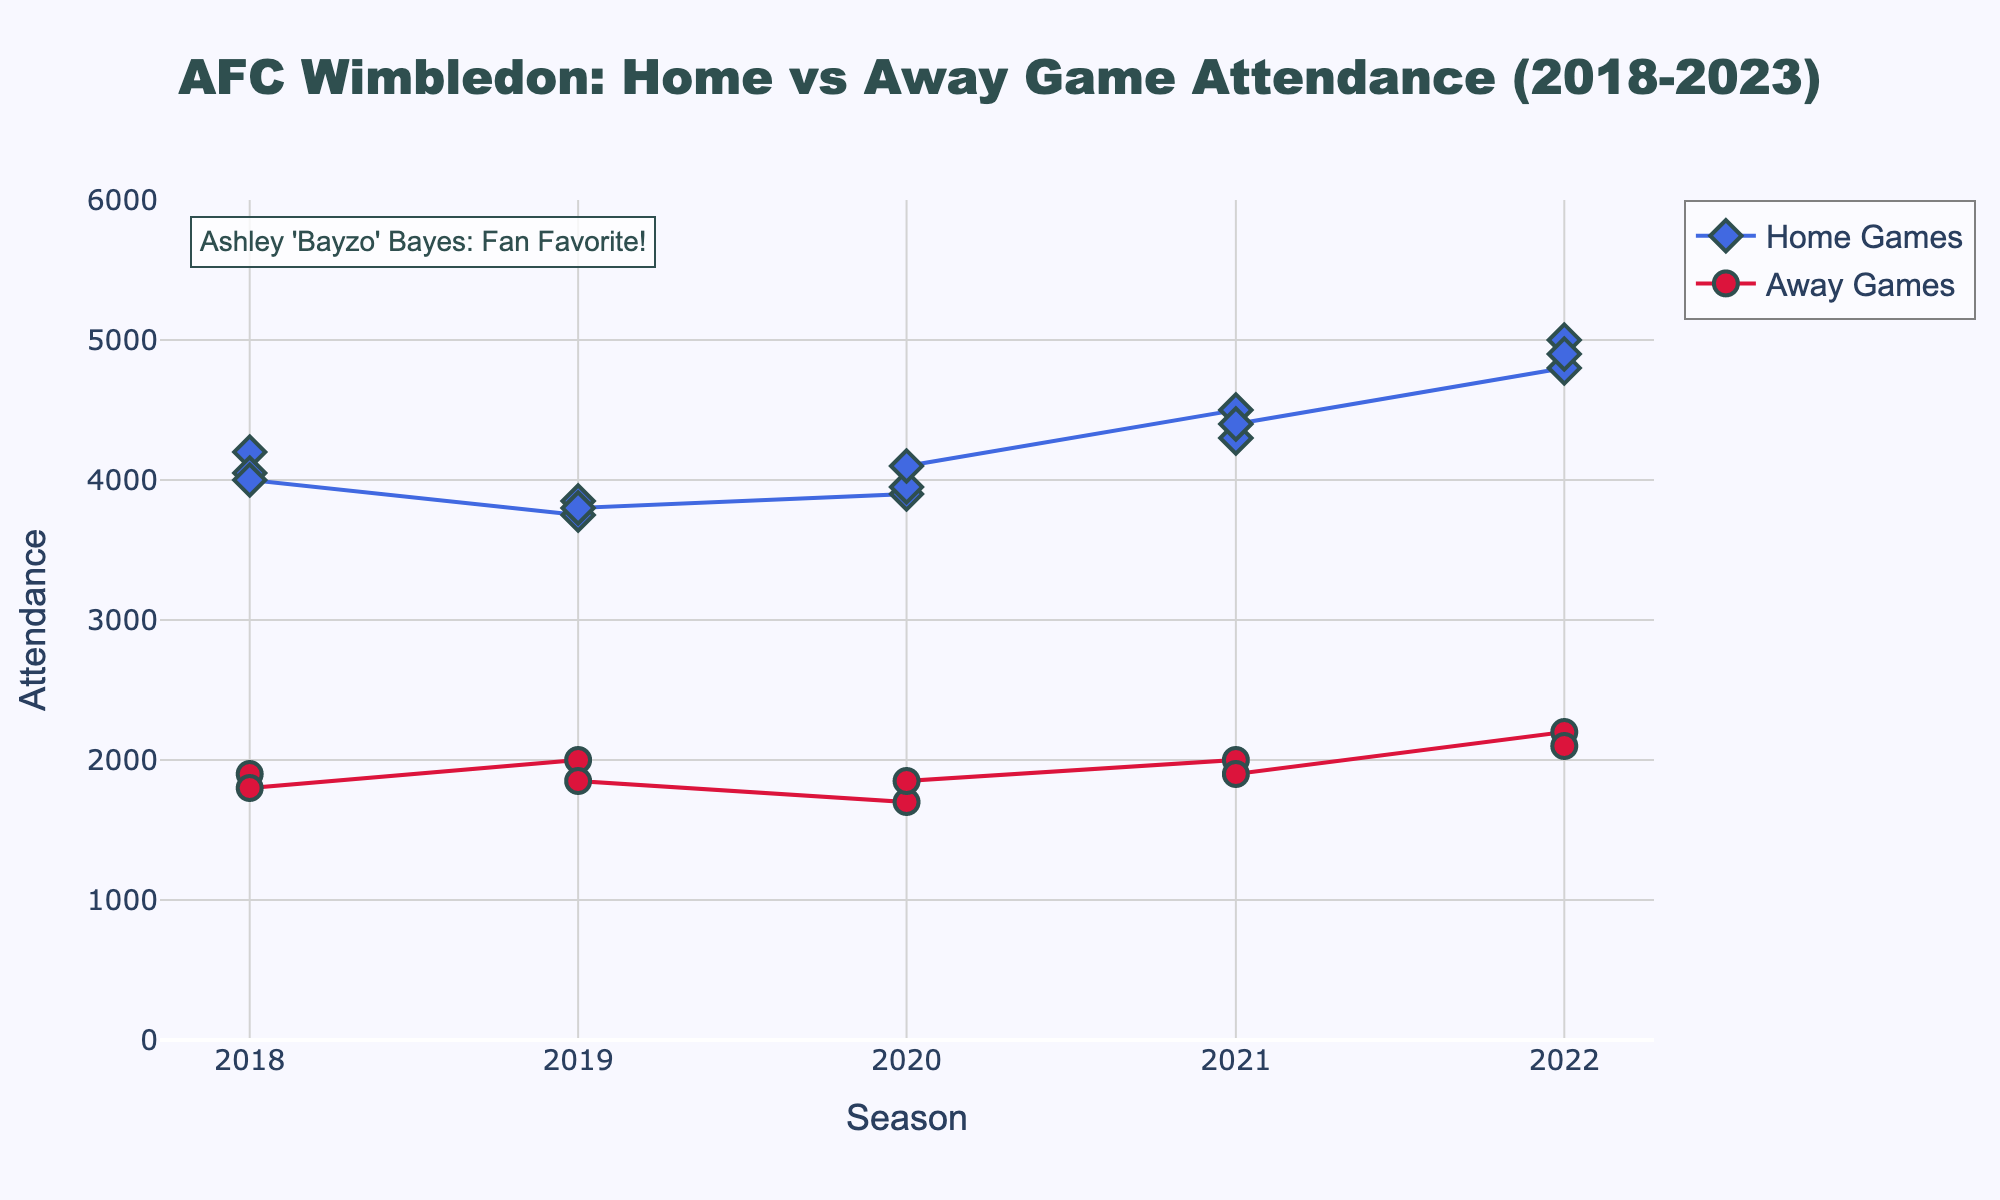What is the title of the scatter plot? The title of the scatter plot is displayed prominently at the top of the plot. It should be easy to spot and clearly indicates what the plot represents.
Answer: AFC Wimbledon: Home vs Away Game Attendance (2018-2023) What colors are used to differentiate between home and away games? The colors used to differentiate between home and away games can be identified by looking at the legend in the plot. The home games are usually represented in blue, and the away games are represented in red.
Answer: Blue for Home, Red for Away How many seasons are covered in the scatter plot? The x-axis represents the seasons, which are marked clearly. By counting these marks from the beginning to the end of the axis, we can determine the number of seasons covered.
Answer: 5 What is the range of attendance for home games? To answer this, we look at the y-values of the points marked for home games. By identifying the minimum and maximum y-values among these points, we find the range.
Answer: 3750 to 5000 What is the average attendance for away games during the 2020/21 season? First, locate the away games for the 2020/21 season. The y-values for these points represent the attendance numbers. Adding these values and then dividing by the number of points provides the average.
Answer: 1775 Which game had the highest attendance, and what was the attendance number? Identify the point with the highest y-value in the scatter plot and note the corresponding game from the legend or annotation near the point.
Answer: Home vs Milton Keynes Dons, 5000 Has the attendance for home games increased or decreased over the seasons? By observing the trend of the lines connecting the points for home games from the start to the end, we can determine if there's an overall upward or downward trend.
Answer: Increased Compare the average attendance for home games to away games for the 2021/22 season. Identify the points corresponding to the 2021/22 season for both home and away games. Calculate the average for each type by summing the y-values and dividing by the number of points. Compare these averages.
Answer: Home: 4400, Away: 1950 Is there a larger variability in attendance for home or away games? We examine the spread of the y-values for both home and away games. The type with a wider spread (greater variance) has larger variability.
Answer: Away games In which season did away games have the highest attendance on average? For each season, calculate the average attendance for away games by adding the y-values and dividing by the number of points for that season. Compare these averages across the seasons.
Answer: 2022/23 